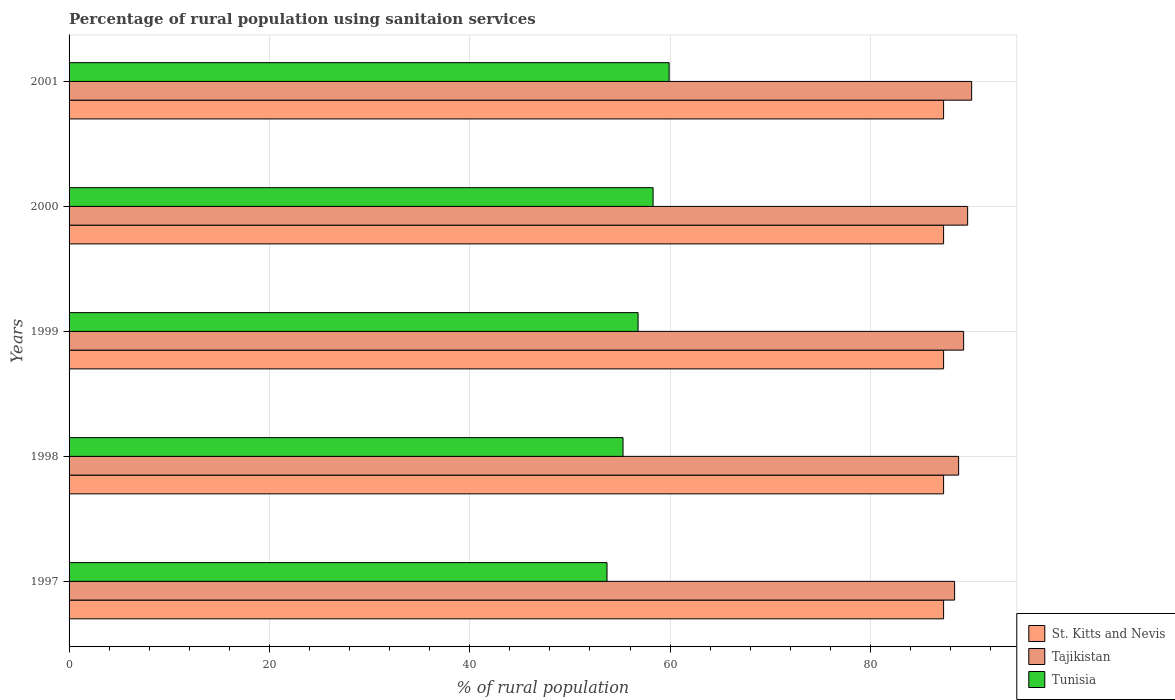How many different coloured bars are there?
Ensure brevity in your answer.  3. Are the number of bars per tick equal to the number of legend labels?
Keep it short and to the point. Yes. Are the number of bars on each tick of the Y-axis equal?
Provide a short and direct response. Yes. How many bars are there on the 1st tick from the top?
Your response must be concise. 3. What is the percentage of rural population using sanitaion services in St. Kitts and Nevis in 1997?
Offer a terse response. 87.3. Across all years, what is the maximum percentage of rural population using sanitaion services in Tajikistan?
Your response must be concise. 90.1. Across all years, what is the minimum percentage of rural population using sanitaion services in St. Kitts and Nevis?
Offer a very short reply. 87.3. In which year was the percentage of rural population using sanitaion services in Tajikistan maximum?
Your answer should be compact. 2001. In which year was the percentage of rural population using sanitaion services in Tunisia minimum?
Keep it short and to the point. 1997. What is the total percentage of rural population using sanitaion services in St. Kitts and Nevis in the graph?
Your answer should be very brief. 436.5. What is the difference between the percentage of rural population using sanitaion services in Tunisia in 1997 and that in 2000?
Make the answer very short. -4.6. What is the difference between the percentage of rural population using sanitaion services in Tajikistan in 2000 and the percentage of rural population using sanitaion services in St. Kitts and Nevis in 1998?
Ensure brevity in your answer.  2.4. What is the average percentage of rural population using sanitaion services in Tunisia per year?
Your response must be concise. 56.8. In the year 2001, what is the difference between the percentage of rural population using sanitaion services in St. Kitts and Nevis and percentage of rural population using sanitaion services in Tajikistan?
Your answer should be very brief. -2.8. In how many years, is the percentage of rural population using sanitaion services in Tunisia greater than 76 %?
Provide a short and direct response. 0. What is the ratio of the percentage of rural population using sanitaion services in Tajikistan in 2000 to that in 2001?
Your response must be concise. 1. Is the difference between the percentage of rural population using sanitaion services in St. Kitts and Nevis in 1997 and 1998 greater than the difference between the percentage of rural population using sanitaion services in Tajikistan in 1997 and 1998?
Provide a succinct answer. Yes. What is the difference between the highest and the second highest percentage of rural population using sanitaion services in Tajikistan?
Ensure brevity in your answer.  0.4. What is the difference between the highest and the lowest percentage of rural population using sanitaion services in St. Kitts and Nevis?
Keep it short and to the point. 0. In how many years, is the percentage of rural population using sanitaion services in St. Kitts and Nevis greater than the average percentage of rural population using sanitaion services in St. Kitts and Nevis taken over all years?
Offer a terse response. 0. Is the sum of the percentage of rural population using sanitaion services in St. Kitts and Nevis in 1998 and 2000 greater than the maximum percentage of rural population using sanitaion services in Tunisia across all years?
Ensure brevity in your answer.  Yes. What does the 3rd bar from the top in 2001 represents?
Offer a terse response. St. Kitts and Nevis. What does the 1st bar from the bottom in 1997 represents?
Make the answer very short. St. Kitts and Nevis. Are all the bars in the graph horizontal?
Your answer should be compact. Yes. How many years are there in the graph?
Your answer should be compact. 5. Does the graph contain grids?
Offer a terse response. Yes. Where does the legend appear in the graph?
Keep it short and to the point. Bottom right. How many legend labels are there?
Provide a short and direct response. 3. How are the legend labels stacked?
Your answer should be very brief. Vertical. What is the title of the graph?
Provide a short and direct response. Percentage of rural population using sanitaion services. What is the label or title of the X-axis?
Keep it short and to the point. % of rural population. What is the % of rural population in St. Kitts and Nevis in 1997?
Offer a very short reply. 87.3. What is the % of rural population in Tajikistan in 1997?
Keep it short and to the point. 88.4. What is the % of rural population of Tunisia in 1997?
Your answer should be compact. 53.7. What is the % of rural population of St. Kitts and Nevis in 1998?
Ensure brevity in your answer.  87.3. What is the % of rural population in Tajikistan in 1998?
Give a very brief answer. 88.8. What is the % of rural population in Tunisia in 1998?
Provide a short and direct response. 55.3. What is the % of rural population in St. Kitts and Nevis in 1999?
Provide a succinct answer. 87.3. What is the % of rural population of Tajikistan in 1999?
Your answer should be very brief. 89.3. What is the % of rural population of Tunisia in 1999?
Offer a terse response. 56.8. What is the % of rural population in St. Kitts and Nevis in 2000?
Your response must be concise. 87.3. What is the % of rural population of Tajikistan in 2000?
Make the answer very short. 89.7. What is the % of rural population in Tunisia in 2000?
Ensure brevity in your answer.  58.3. What is the % of rural population in St. Kitts and Nevis in 2001?
Make the answer very short. 87.3. What is the % of rural population of Tajikistan in 2001?
Ensure brevity in your answer.  90.1. What is the % of rural population of Tunisia in 2001?
Offer a terse response. 59.9. Across all years, what is the maximum % of rural population in St. Kitts and Nevis?
Ensure brevity in your answer.  87.3. Across all years, what is the maximum % of rural population in Tajikistan?
Ensure brevity in your answer.  90.1. Across all years, what is the maximum % of rural population in Tunisia?
Your answer should be very brief. 59.9. Across all years, what is the minimum % of rural population in St. Kitts and Nevis?
Provide a short and direct response. 87.3. Across all years, what is the minimum % of rural population of Tajikistan?
Your answer should be compact. 88.4. Across all years, what is the minimum % of rural population in Tunisia?
Your answer should be very brief. 53.7. What is the total % of rural population in St. Kitts and Nevis in the graph?
Offer a terse response. 436.5. What is the total % of rural population of Tajikistan in the graph?
Give a very brief answer. 446.3. What is the total % of rural population in Tunisia in the graph?
Provide a succinct answer. 284. What is the difference between the % of rural population of St. Kitts and Nevis in 1997 and that in 1998?
Ensure brevity in your answer.  0. What is the difference between the % of rural population of Tunisia in 1997 and that in 1998?
Provide a succinct answer. -1.6. What is the difference between the % of rural population of St. Kitts and Nevis in 1997 and that in 1999?
Ensure brevity in your answer.  0. What is the difference between the % of rural population in Tajikistan in 1997 and that in 1999?
Your response must be concise. -0.9. What is the difference between the % of rural population in Tunisia in 1997 and that in 1999?
Keep it short and to the point. -3.1. What is the difference between the % of rural population in St. Kitts and Nevis in 1997 and that in 2000?
Ensure brevity in your answer.  0. What is the difference between the % of rural population in St. Kitts and Nevis in 1997 and that in 2001?
Provide a short and direct response. 0. What is the difference between the % of rural population in Tajikistan in 1997 and that in 2001?
Offer a terse response. -1.7. What is the difference between the % of rural population in Tunisia in 1997 and that in 2001?
Make the answer very short. -6.2. What is the difference between the % of rural population of St. Kitts and Nevis in 1998 and that in 1999?
Offer a very short reply. 0. What is the difference between the % of rural population of Tajikistan in 1998 and that in 2000?
Provide a succinct answer. -0.9. What is the difference between the % of rural population of Tajikistan in 1999 and that in 2000?
Your answer should be very brief. -0.4. What is the difference between the % of rural population of Tunisia in 1999 and that in 2000?
Your answer should be very brief. -1.5. What is the difference between the % of rural population in St. Kitts and Nevis in 1999 and that in 2001?
Ensure brevity in your answer.  0. What is the difference between the % of rural population in Tajikistan in 1999 and that in 2001?
Make the answer very short. -0.8. What is the difference between the % of rural population in Tunisia in 1999 and that in 2001?
Your answer should be compact. -3.1. What is the difference between the % of rural population of St. Kitts and Nevis in 2000 and that in 2001?
Your response must be concise. 0. What is the difference between the % of rural population of Tajikistan in 2000 and that in 2001?
Offer a terse response. -0.4. What is the difference between the % of rural population of St. Kitts and Nevis in 1997 and the % of rural population of Tajikistan in 1998?
Ensure brevity in your answer.  -1.5. What is the difference between the % of rural population in Tajikistan in 1997 and the % of rural population in Tunisia in 1998?
Provide a succinct answer. 33.1. What is the difference between the % of rural population in St. Kitts and Nevis in 1997 and the % of rural population in Tunisia in 1999?
Make the answer very short. 30.5. What is the difference between the % of rural population of Tajikistan in 1997 and the % of rural population of Tunisia in 1999?
Offer a terse response. 31.6. What is the difference between the % of rural population of Tajikistan in 1997 and the % of rural population of Tunisia in 2000?
Offer a terse response. 30.1. What is the difference between the % of rural population of St. Kitts and Nevis in 1997 and the % of rural population of Tunisia in 2001?
Offer a terse response. 27.4. What is the difference between the % of rural population of Tajikistan in 1997 and the % of rural population of Tunisia in 2001?
Your response must be concise. 28.5. What is the difference between the % of rural population of St. Kitts and Nevis in 1998 and the % of rural population of Tajikistan in 1999?
Offer a very short reply. -2. What is the difference between the % of rural population of St. Kitts and Nevis in 1998 and the % of rural population of Tunisia in 1999?
Ensure brevity in your answer.  30.5. What is the difference between the % of rural population in St. Kitts and Nevis in 1998 and the % of rural population in Tunisia in 2000?
Your answer should be very brief. 29. What is the difference between the % of rural population of Tajikistan in 1998 and the % of rural population of Tunisia in 2000?
Offer a terse response. 30.5. What is the difference between the % of rural population in St. Kitts and Nevis in 1998 and the % of rural population in Tajikistan in 2001?
Your answer should be compact. -2.8. What is the difference between the % of rural population of St. Kitts and Nevis in 1998 and the % of rural population of Tunisia in 2001?
Provide a succinct answer. 27.4. What is the difference between the % of rural population in Tajikistan in 1998 and the % of rural population in Tunisia in 2001?
Keep it short and to the point. 28.9. What is the difference between the % of rural population in St. Kitts and Nevis in 1999 and the % of rural population in Tunisia in 2000?
Keep it short and to the point. 29. What is the difference between the % of rural population in Tajikistan in 1999 and the % of rural population in Tunisia in 2000?
Provide a succinct answer. 31. What is the difference between the % of rural population of St. Kitts and Nevis in 1999 and the % of rural population of Tunisia in 2001?
Your response must be concise. 27.4. What is the difference between the % of rural population of Tajikistan in 1999 and the % of rural population of Tunisia in 2001?
Make the answer very short. 29.4. What is the difference between the % of rural population in St. Kitts and Nevis in 2000 and the % of rural population in Tunisia in 2001?
Ensure brevity in your answer.  27.4. What is the difference between the % of rural population in Tajikistan in 2000 and the % of rural population in Tunisia in 2001?
Ensure brevity in your answer.  29.8. What is the average % of rural population of St. Kitts and Nevis per year?
Offer a very short reply. 87.3. What is the average % of rural population of Tajikistan per year?
Your answer should be compact. 89.26. What is the average % of rural population of Tunisia per year?
Give a very brief answer. 56.8. In the year 1997, what is the difference between the % of rural population of St. Kitts and Nevis and % of rural population of Tunisia?
Your answer should be compact. 33.6. In the year 1997, what is the difference between the % of rural population of Tajikistan and % of rural population of Tunisia?
Keep it short and to the point. 34.7. In the year 1998, what is the difference between the % of rural population of Tajikistan and % of rural population of Tunisia?
Your response must be concise. 33.5. In the year 1999, what is the difference between the % of rural population in St. Kitts and Nevis and % of rural population in Tajikistan?
Keep it short and to the point. -2. In the year 1999, what is the difference between the % of rural population in St. Kitts and Nevis and % of rural population in Tunisia?
Ensure brevity in your answer.  30.5. In the year 1999, what is the difference between the % of rural population of Tajikistan and % of rural population of Tunisia?
Keep it short and to the point. 32.5. In the year 2000, what is the difference between the % of rural population in St. Kitts and Nevis and % of rural population in Tajikistan?
Your answer should be very brief. -2.4. In the year 2000, what is the difference between the % of rural population in Tajikistan and % of rural population in Tunisia?
Your answer should be very brief. 31.4. In the year 2001, what is the difference between the % of rural population of St. Kitts and Nevis and % of rural population of Tunisia?
Provide a succinct answer. 27.4. In the year 2001, what is the difference between the % of rural population of Tajikistan and % of rural population of Tunisia?
Your response must be concise. 30.2. What is the ratio of the % of rural population in Tajikistan in 1997 to that in 1998?
Provide a short and direct response. 1. What is the ratio of the % of rural population in Tunisia in 1997 to that in 1998?
Provide a succinct answer. 0.97. What is the ratio of the % of rural population of Tajikistan in 1997 to that in 1999?
Provide a short and direct response. 0.99. What is the ratio of the % of rural population in Tunisia in 1997 to that in 1999?
Offer a very short reply. 0.95. What is the ratio of the % of rural population in St. Kitts and Nevis in 1997 to that in 2000?
Your response must be concise. 1. What is the ratio of the % of rural population of Tajikistan in 1997 to that in 2000?
Make the answer very short. 0.99. What is the ratio of the % of rural population of Tunisia in 1997 to that in 2000?
Keep it short and to the point. 0.92. What is the ratio of the % of rural population of St. Kitts and Nevis in 1997 to that in 2001?
Your answer should be very brief. 1. What is the ratio of the % of rural population of Tajikistan in 1997 to that in 2001?
Your response must be concise. 0.98. What is the ratio of the % of rural population in Tunisia in 1997 to that in 2001?
Your response must be concise. 0.9. What is the ratio of the % of rural population of St. Kitts and Nevis in 1998 to that in 1999?
Your answer should be very brief. 1. What is the ratio of the % of rural population in Tunisia in 1998 to that in 1999?
Keep it short and to the point. 0.97. What is the ratio of the % of rural population of St. Kitts and Nevis in 1998 to that in 2000?
Your answer should be very brief. 1. What is the ratio of the % of rural population of Tajikistan in 1998 to that in 2000?
Your answer should be very brief. 0.99. What is the ratio of the % of rural population of Tunisia in 1998 to that in 2000?
Give a very brief answer. 0.95. What is the ratio of the % of rural population of St. Kitts and Nevis in 1998 to that in 2001?
Your answer should be very brief. 1. What is the ratio of the % of rural population of Tajikistan in 1998 to that in 2001?
Your answer should be very brief. 0.99. What is the ratio of the % of rural population of Tunisia in 1998 to that in 2001?
Your answer should be compact. 0.92. What is the ratio of the % of rural population in St. Kitts and Nevis in 1999 to that in 2000?
Your answer should be compact. 1. What is the ratio of the % of rural population in Tajikistan in 1999 to that in 2000?
Provide a succinct answer. 1. What is the ratio of the % of rural population in Tunisia in 1999 to that in 2000?
Make the answer very short. 0.97. What is the ratio of the % of rural population in St. Kitts and Nevis in 1999 to that in 2001?
Your answer should be very brief. 1. What is the ratio of the % of rural population in Tunisia in 1999 to that in 2001?
Offer a terse response. 0.95. What is the ratio of the % of rural population in St. Kitts and Nevis in 2000 to that in 2001?
Provide a succinct answer. 1. What is the ratio of the % of rural population in Tajikistan in 2000 to that in 2001?
Ensure brevity in your answer.  1. What is the ratio of the % of rural population of Tunisia in 2000 to that in 2001?
Give a very brief answer. 0.97. What is the difference between the highest and the second highest % of rural population in Tunisia?
Ensure brevity in your answer.  1.6. What is the difference between the highest and the lowest % of rural population of Tajikistan?
Your answer should be compact. 1.7. What is the difference between the highest and the lowest % of rural population of Tunisia?
Keep it short and to the point. 6.2. 